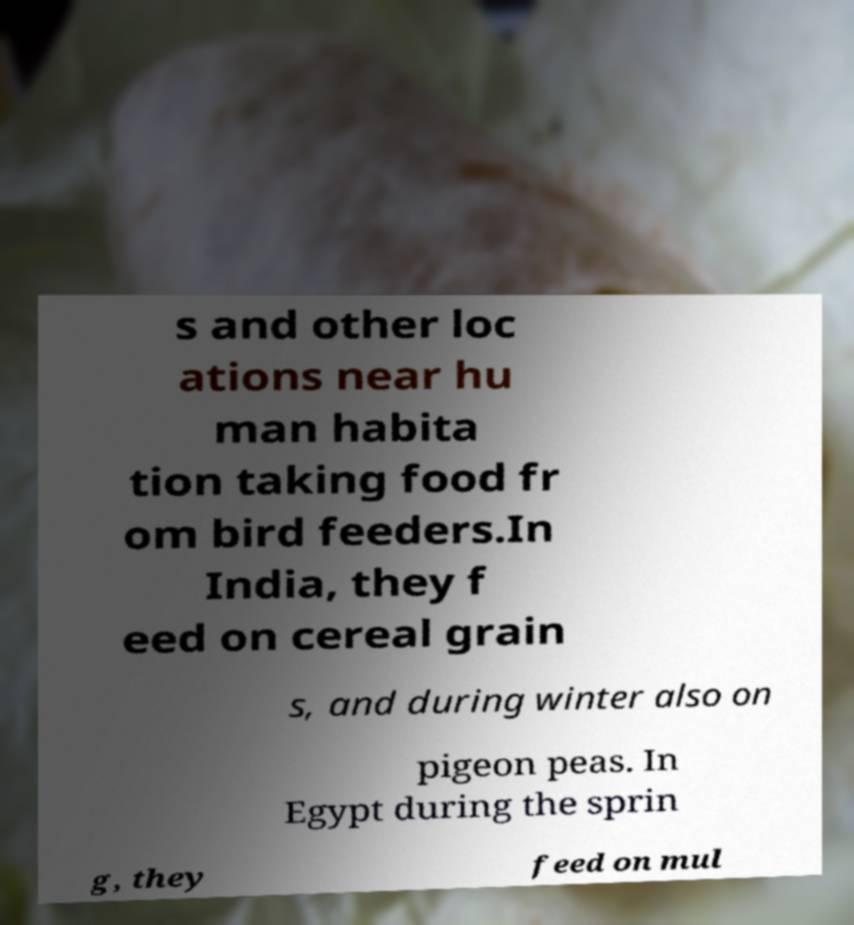Could you assist in decoding the text presented in this image and type it out clearly? s and other loc ations near hu man habita tion taking food fr om bird feeders.In India, they f eed on cereal grain s, and during winter also on pigeon peas. In Egypt during the sprin g, they feed on mul 